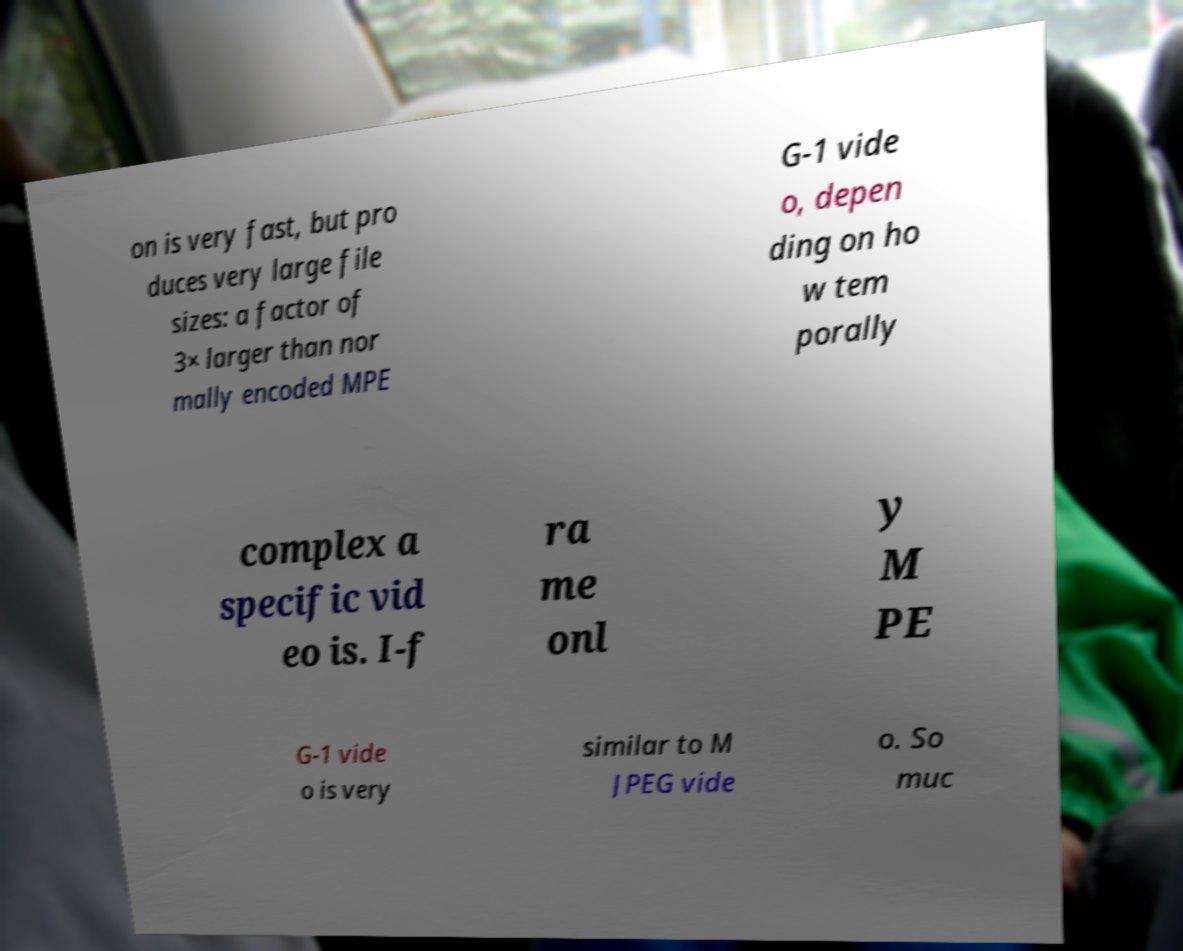Could you extract and type out the text from this image? on is very fast, but pro duces very large file sizes: a factor of 3× larger than nor mally encoded MPE G-1 vide o, depen ding on ho w tem porally complex a specific vid eo is. I-f ra me onl y M PE G-1 vide o is very similar to M JPEG vide o. So muc 